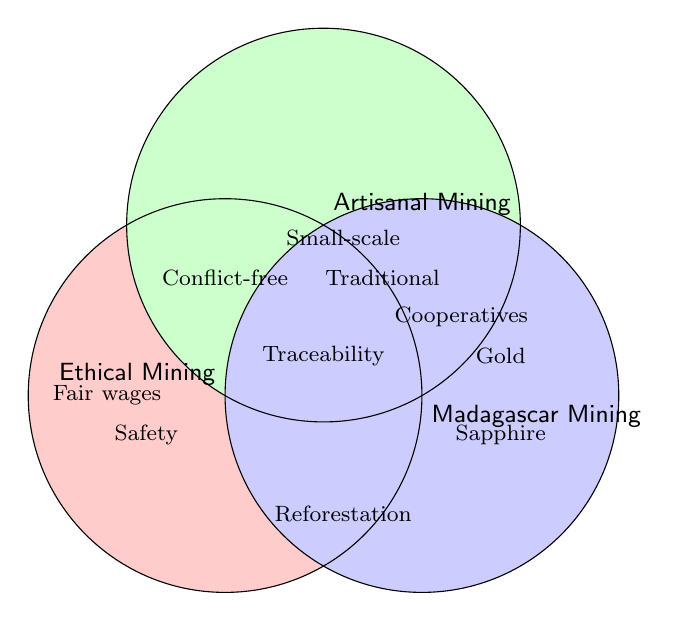What are the unique practices associated with Ethical Mining? Ethical Mining practices are located within the section labeled "Ethical Mining" only. Practices include Fair wages, Environmental protection, and Safety regulations.
Answer: Fair wages, Environmental protection, Safety regulations What practices are common between Ethical Mining and Artisanal Mining? The overlapping section between Ethical Mining and Artisanal Mining shows practices common to both. This section includes Conflict-free sourcing.
Answer: Conflict-free sourcing Which mining type includes the practice of "Cooperative organizations"? "Cooperative organizations" is located in the overlap between Artisanal Mining and Madagascar Mining.
Answer: Artisanal Mining, Madagascar Mining How many practices are shared among Ethical Mining, Artisanal Mining, and Madagascar Mining? The center overlap of all three circles represents practices shared among all three categories. This includes Traceability systems.
Answer: 1 (Traceability systems) Which mining category includes the practice of "Gold panning"? "Gold panning" is in the section labeled "Madagascar Mining" only.
Answer: Madagascar Mining Compare the number of unique practices between Ethical Mining and Artisanal Mining. Ethical Mining has unique practices: Fair wages, Environmental protection, and Safety regulations (3). Artisanal Mining has unique practices: Small-scale operations, Traditional techniques, Local community involvement (3). Both have 3 unique practices each.
Answer: Equal (3 each) What practice appears in the overlap between Madagascar Mining and Ethical Mining? Practices in the overlap between Ethical Mining and Madagascar Mining include Reforestation efforts.
Answer: Reforestation efforts What color is used to represent Ethical Mining? The color used in the Venn Diagram for Ethical Mining can be identified by the shading in its section. The color is a shade of light red/pink.
Answer: Light red/pink Identify a practice found exclusively within Artisanal Mining but not shared with any other mining types. Exclusive practices to Artisanal Mining include Small-scale operations, Traditional techniques, and Local community involvement.
Answer: Small-scale operations, Traditional techniques, Local community involvement 